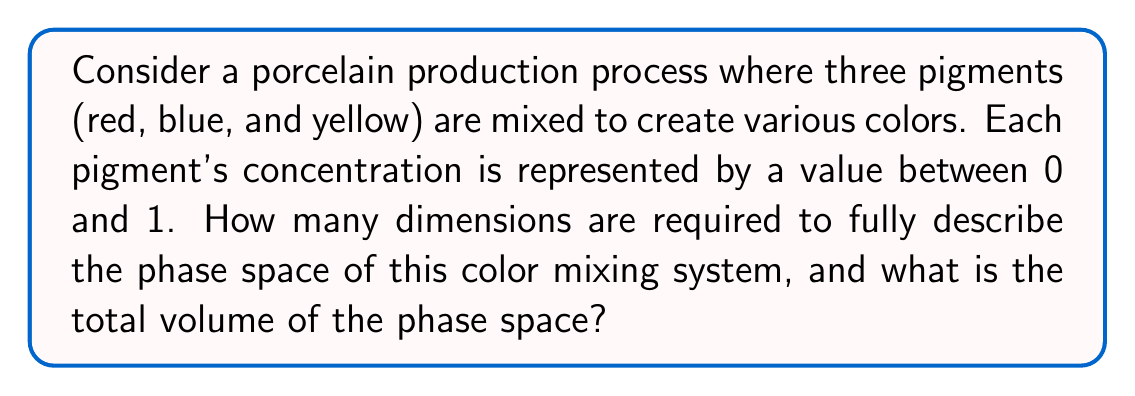Can you answer this question? 1. Determine the number of dimensions:
   - Each pigment concentration is an independent variable.
   - We have three pigments: red, blue, and yellow.
   - Therefore, the phase space has 3 dimensions.

2. Define the phase space:
   - Each dimension represents a pigment concentration from 0 to 1.
   - The phase space is a cube with sides of length 1.

3. Calculate the volume of the phase space:
   - Volume of a cube: $V = s^3$, where $s$ is the side length.
   - In this case, $s = 1$.
   - $V = 1^3 = 1$ cubic unit.

4. Interpret the result:
   - The phase space is a 3-dimensional unit cube.
   - Each point in this cube represents a unique color mixture.
   - The total volume of 1 cubic unit encompasses all possible color combinations.

5. Chaos theory connection:
   - Small changes in initial pigment concentrations can lead to significantly different final colors, exhibiting sensitivity to initial conditions characteristic of chaotic systems.
Answer: 3 dimensions; 1 cubic unit 